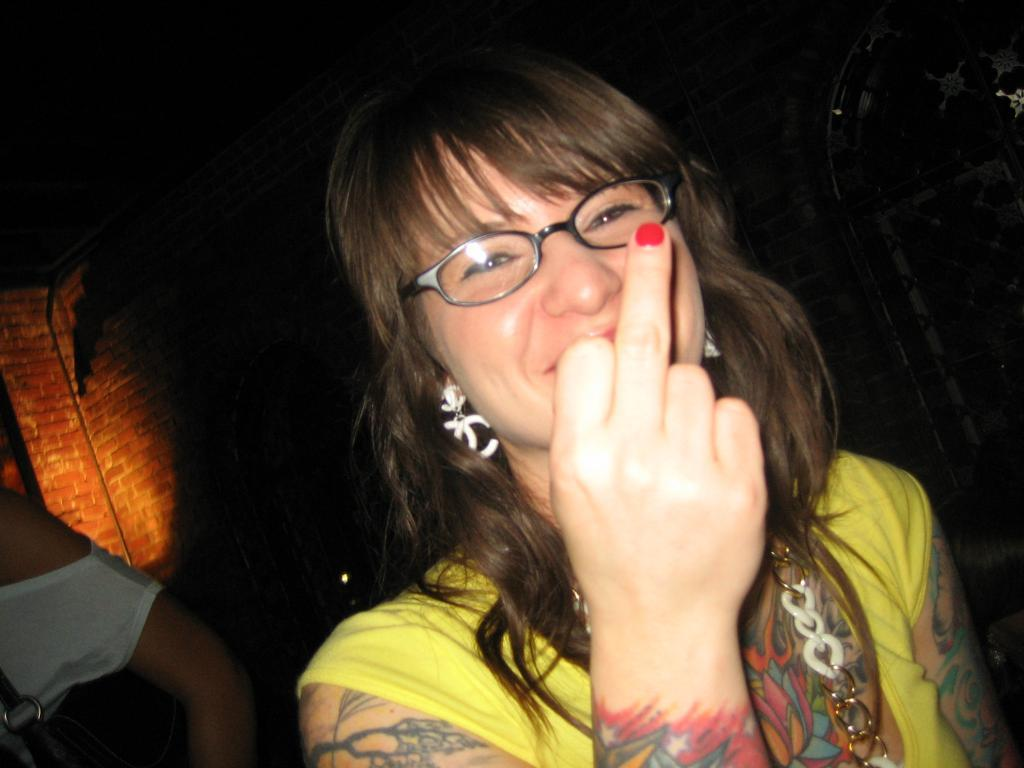Who is the main subject in the image? There is a woman in the center of the image. What is the woman wearing in the image? The woman is wearing spectacles in the image. What can be seen in the background of the image? There is a wall in the background of the image. How does the woman feel about the shocking news she received at night in the image? There is no indication of any news, shock, or nighttime setting in the image. The image only shows a woman wearing spectacles in the center of the image with a wall in the background. 